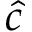Convert formula to latex. <formula><loc_0><loc_0><loc_500><loc_500>\hat { c }</formula> 